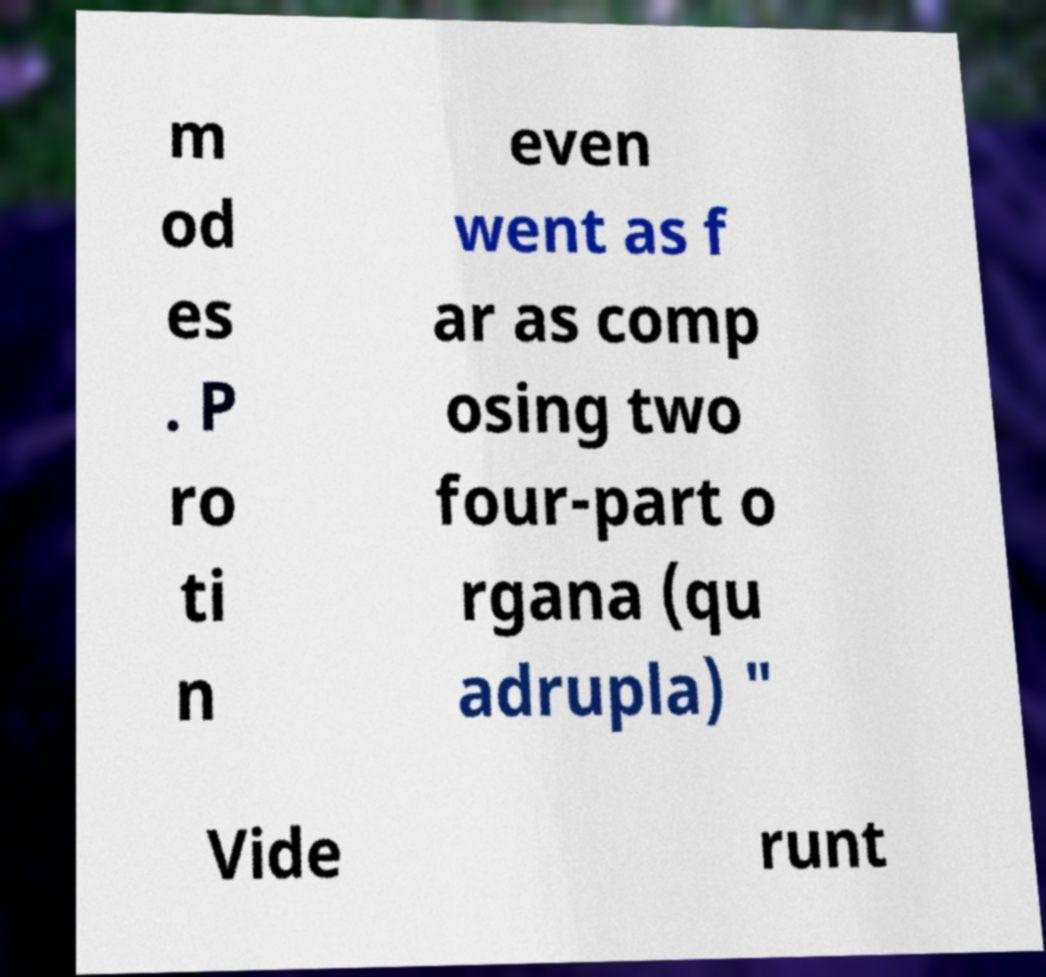For documentation purposes, I need the text within this image transcribed. Could you provide that? m od es . P ro ti n even went as f ar as comp osing two four-part o rgana (qu adrupla) " Vide runt 